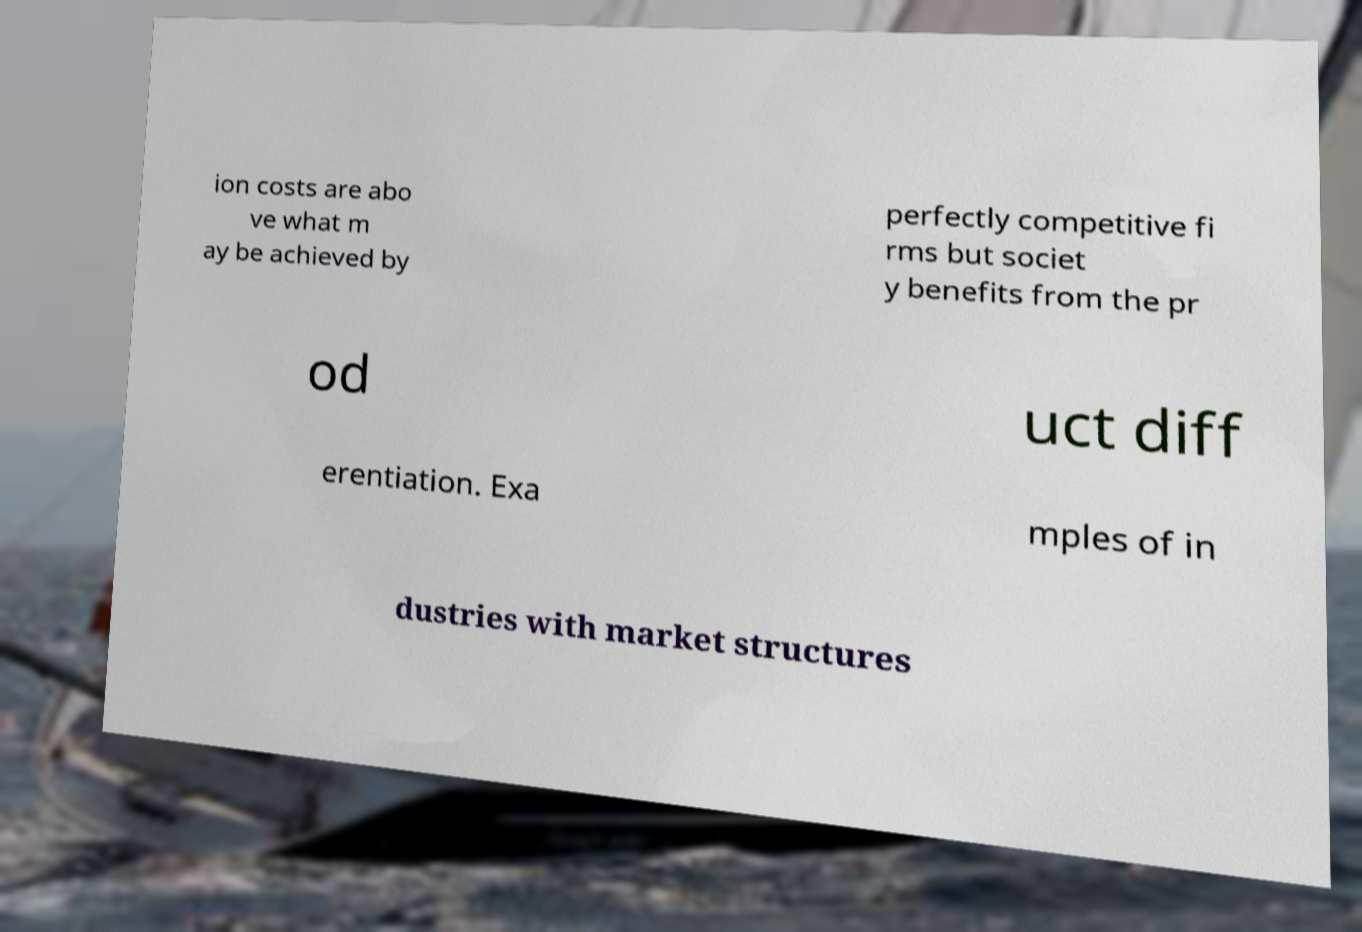Please identify and transcribe the text found in this image. ion costs are abo ve what m ay be achieved by perfectly competitive fi rms but societ y benefits from the pr od uct diff erentiation. Exa mples of in dustries with market structures 